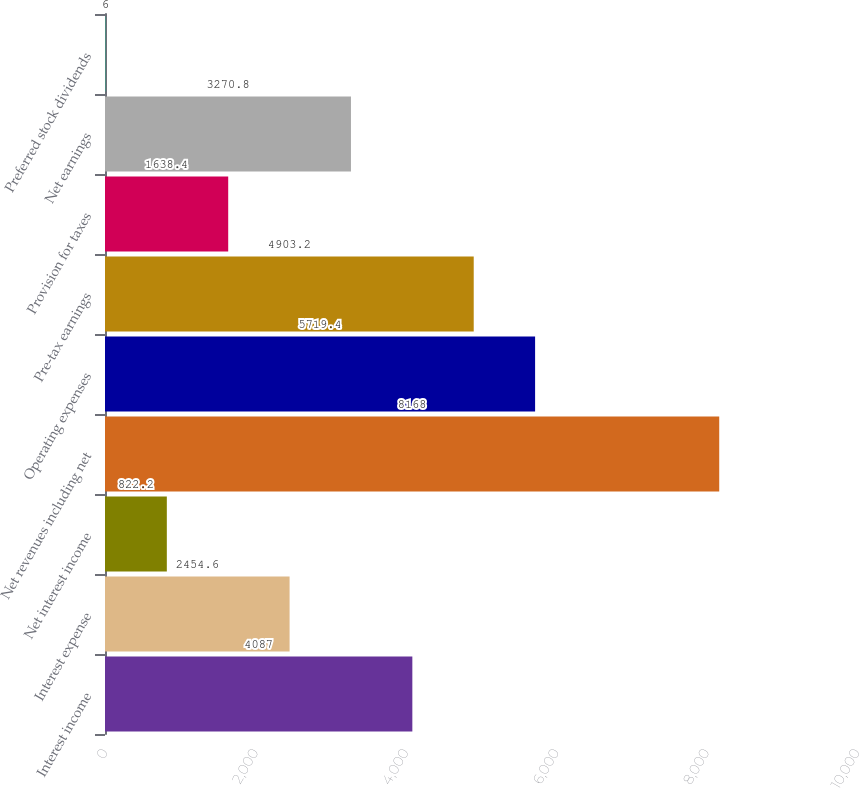<chart> <loc_0><loc_0><loc_500><loc_500><bar_chart><fcel>Interest income<fcel>Interest expense<fcel>Net interest income<fcel>Net revenues including net<fcel>Operating expenses<fcel>Pre-tax earnings<fcel>Provision for taxes<fcel>Net earnings<fcel>Preferred stock dividends<nl><fcel>4087<fcel>2454.6<fcel>822.2<fcel>8168<fcel>5719.4<fcel>4903.2<fcel>1638.4<fcel>3270.8<fcel>6<nl></chart> 